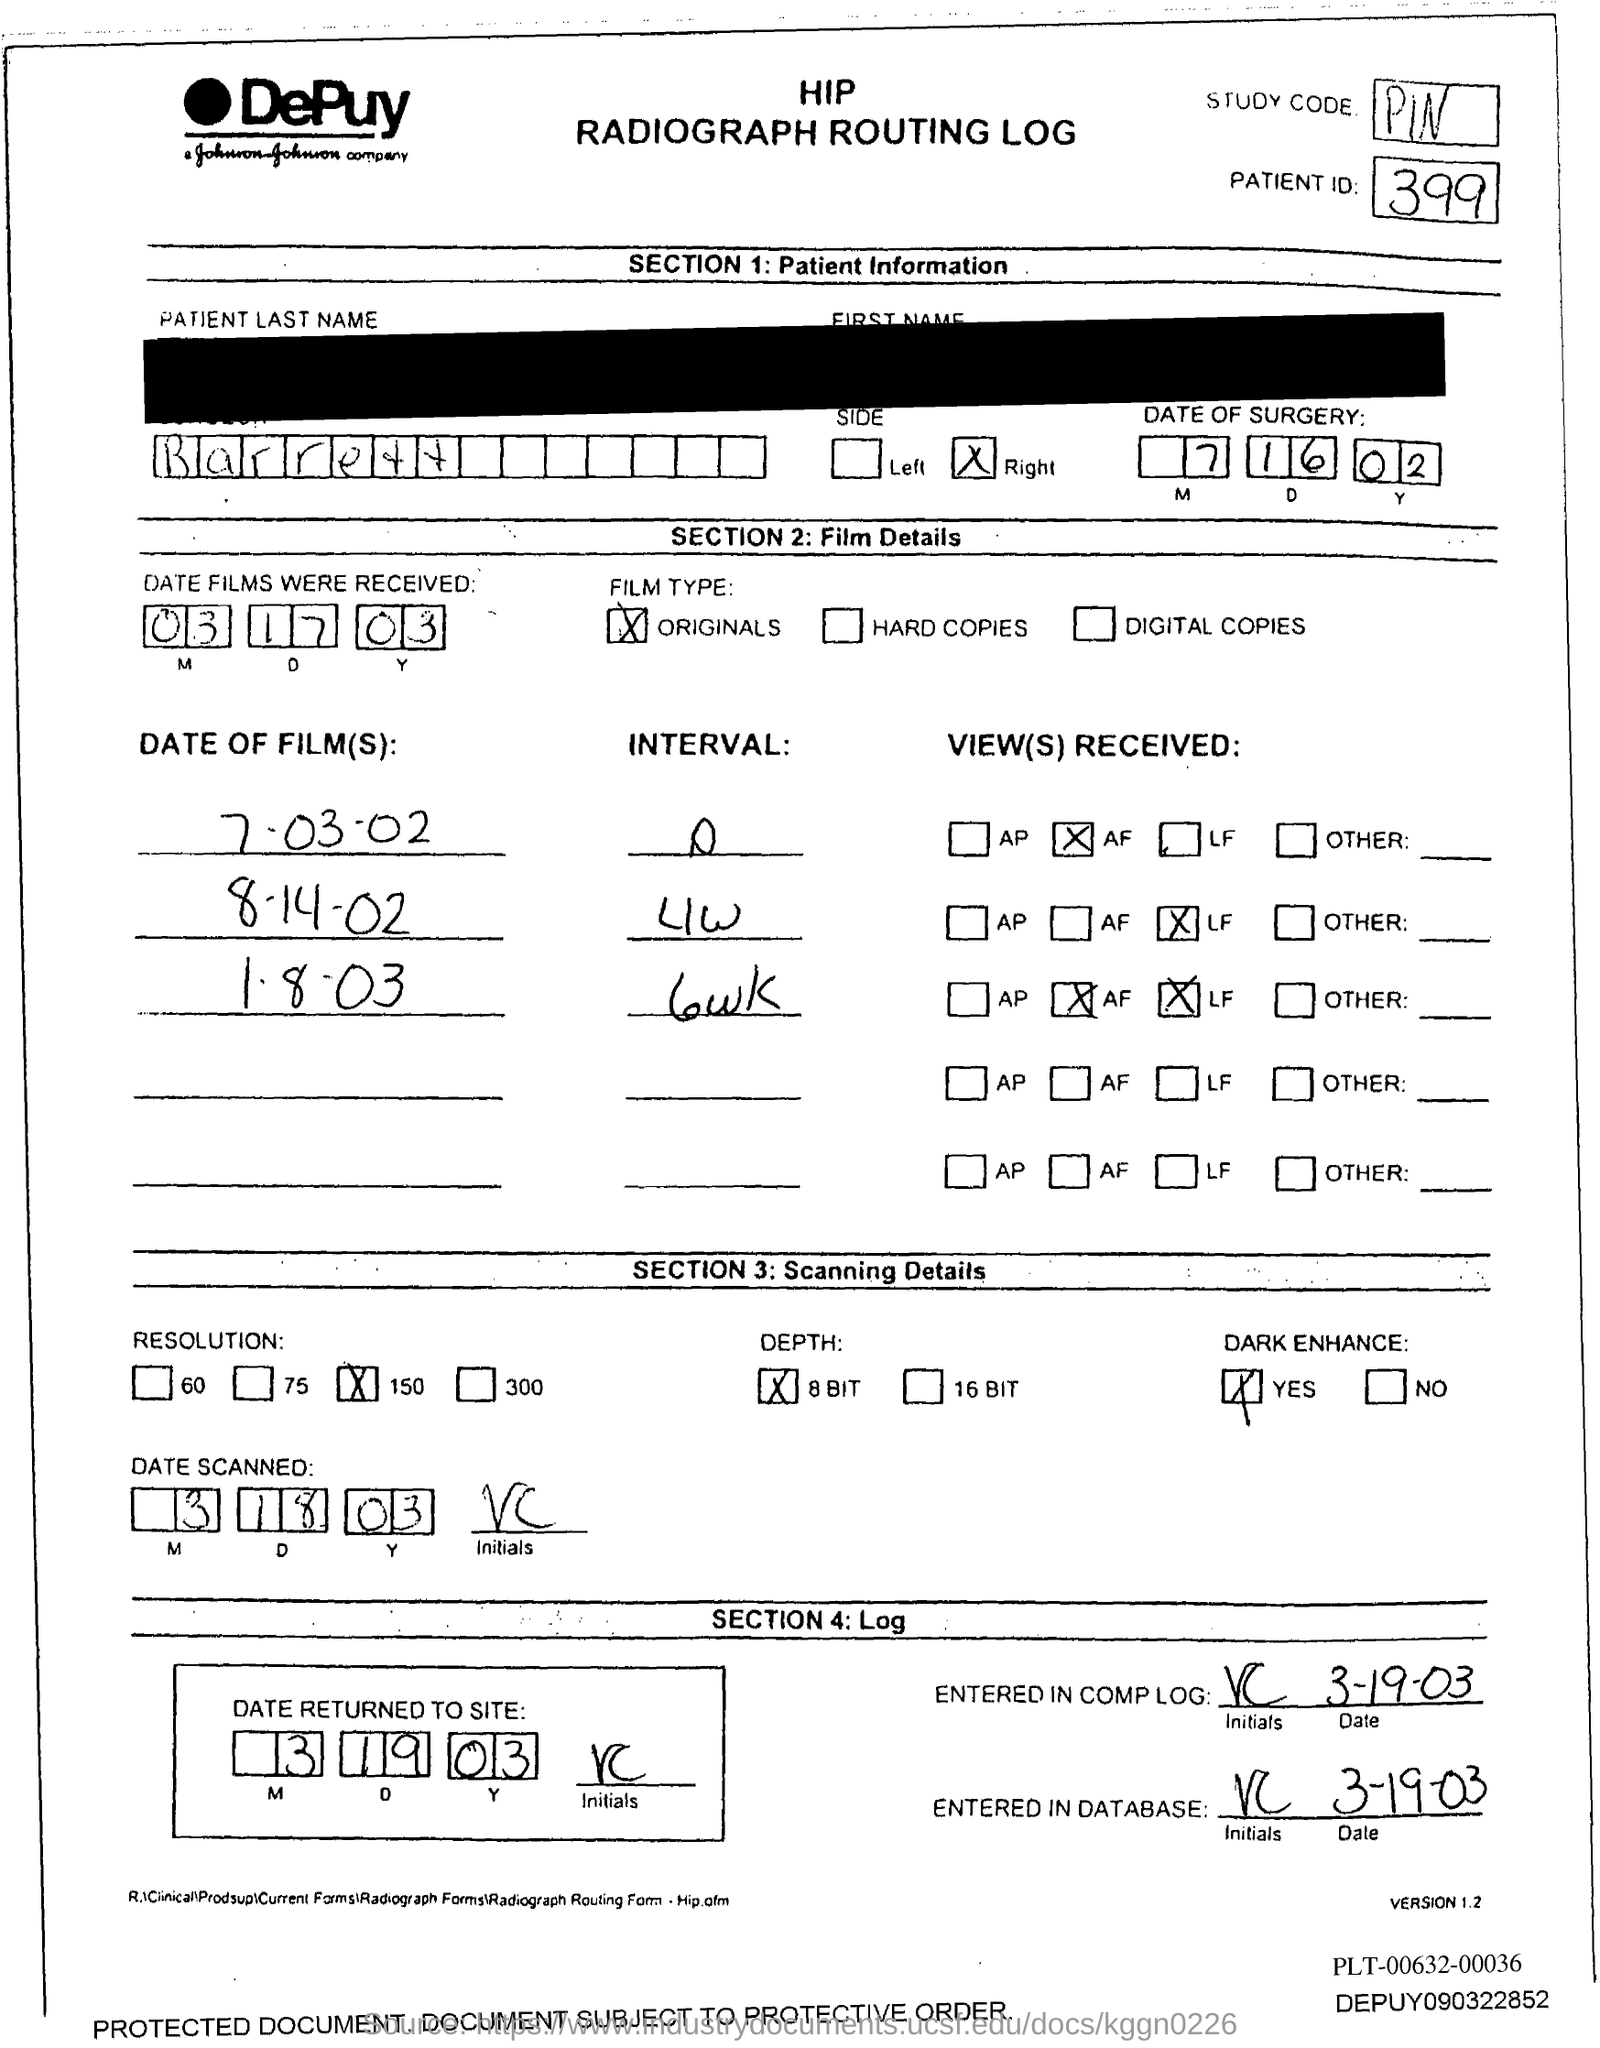What is the study code ?
Give a very brief answer. PIN. What is the patient id.?
Offer a terse response. 399. 